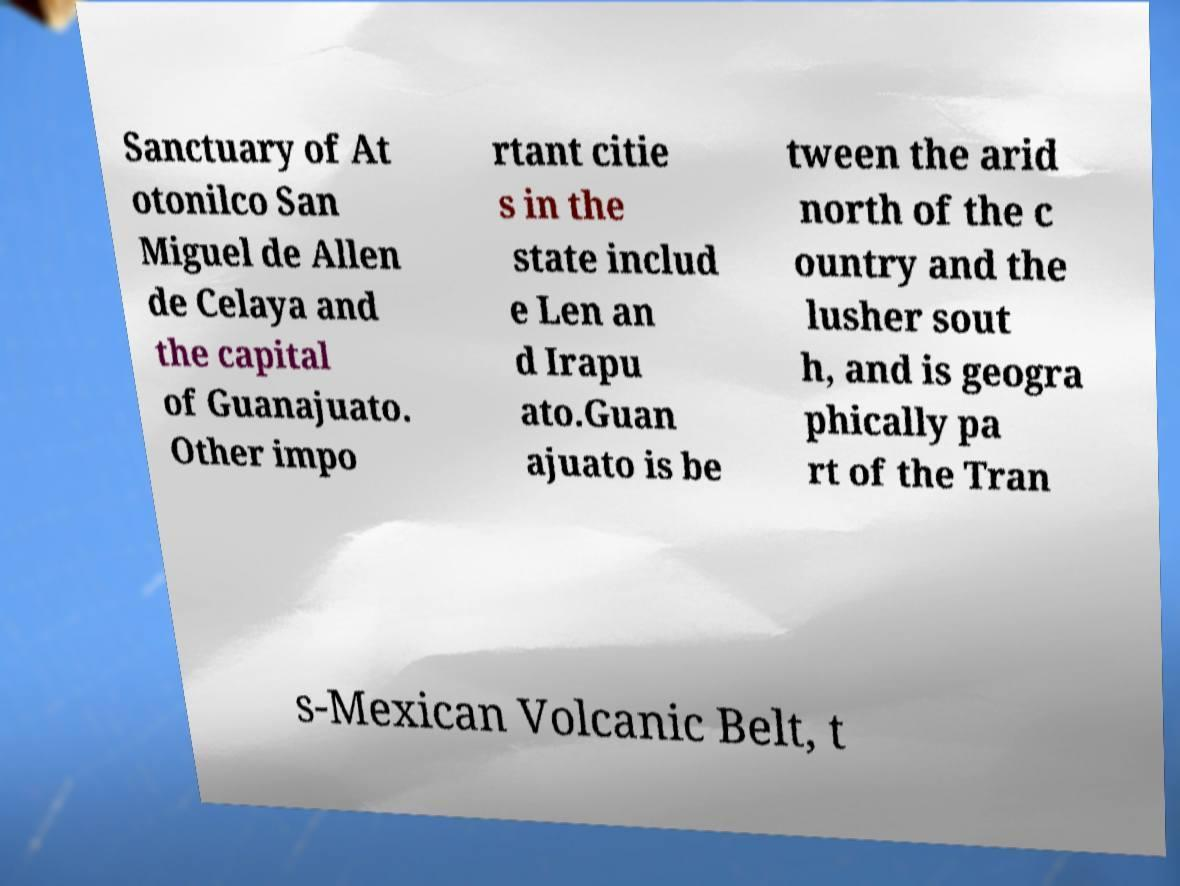Please identify and transcribe the text found in this image. Sanctuary of At otonilco San Miguel de Allen de Celaya and the capital of Guanajuato. Other impo rtant citie s in the state includ e Len an d Irapu ato.Guan ajuato is be tween the arid north of the c ountry and the lusher sout h, and is geogra phically pa rt of the Tran s-Mexican Volcanic Belt, t 